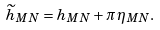Convert formula to latex. <formula><loc_0><loc_0><loc_500><loc_500>\widetilde { h } _ { M N } = h _ { M N } + \pi \, \eta _ { M N } .</formula> 